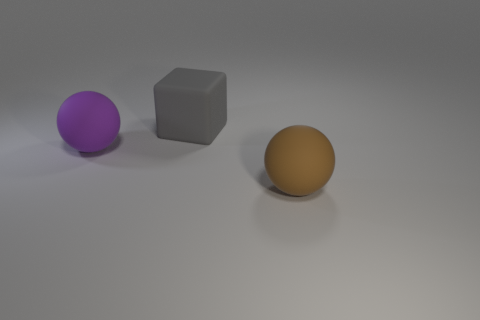Add 3 big red matte spheres. How many objects exist? 6 Subtract all brown balls. How many balls are left? 1 Subtract 1 blocks. How many blocks are left? 0 Subtract all blocks. How many objects are left? 2 Subtract all purple cylinders. How many purple balls are left? 1 Subtract all tiny purple things. Subtract all spheres. How many objects are left? 1 Add 2 spheres. How many spheres are left? 4 Add 3 brown matte balls. How many brown matte balls exist? 4 Subtract 0 blue spheres. How many objects are left? 3 Subtract all brown cubes. Subtract all green cylinders. How many cubes are left? 1 